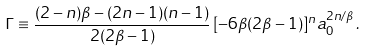<formula> <loc_0><loc_0><loc_500><loc_500>\Gamma \equiv \frac { ( 2 - n ) \beta - ( 2 n - 1 ) ( n - 1 ) } { 2 ( 2 \beta - 1 ) } \, [ - 6 \beta ( 2 \beta - 1 ) ] ^ { n } a _ { 0 } ^ { 2 n / \beta } \, .</formula> 